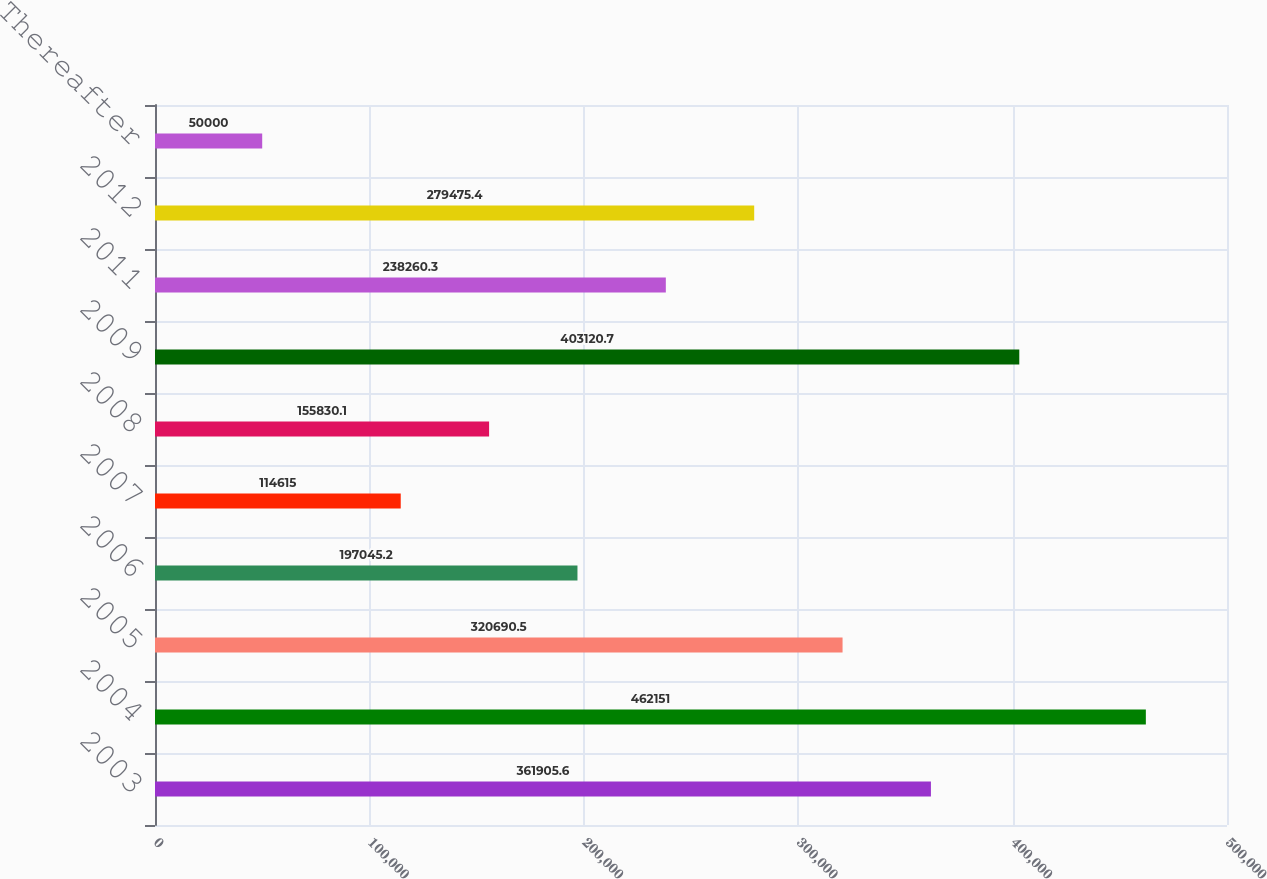<chart> <loc_0><loc_0><loc_500><loc_500><bar_chart><fcel>2003<fcel>2004<fcel>2005<fcel>2006<fcel>2007<fcel>2008<fcel>2009<fcel>2011<fcel>2012<fcel>Thereafter<nl><fcel>361906<fcel>462151<fcel>320690<fcel>197045<fcel>114615<fcel>155830<fcel>403121<fcel>238260<fcel>279475<fcel>50000<nl></chart> 